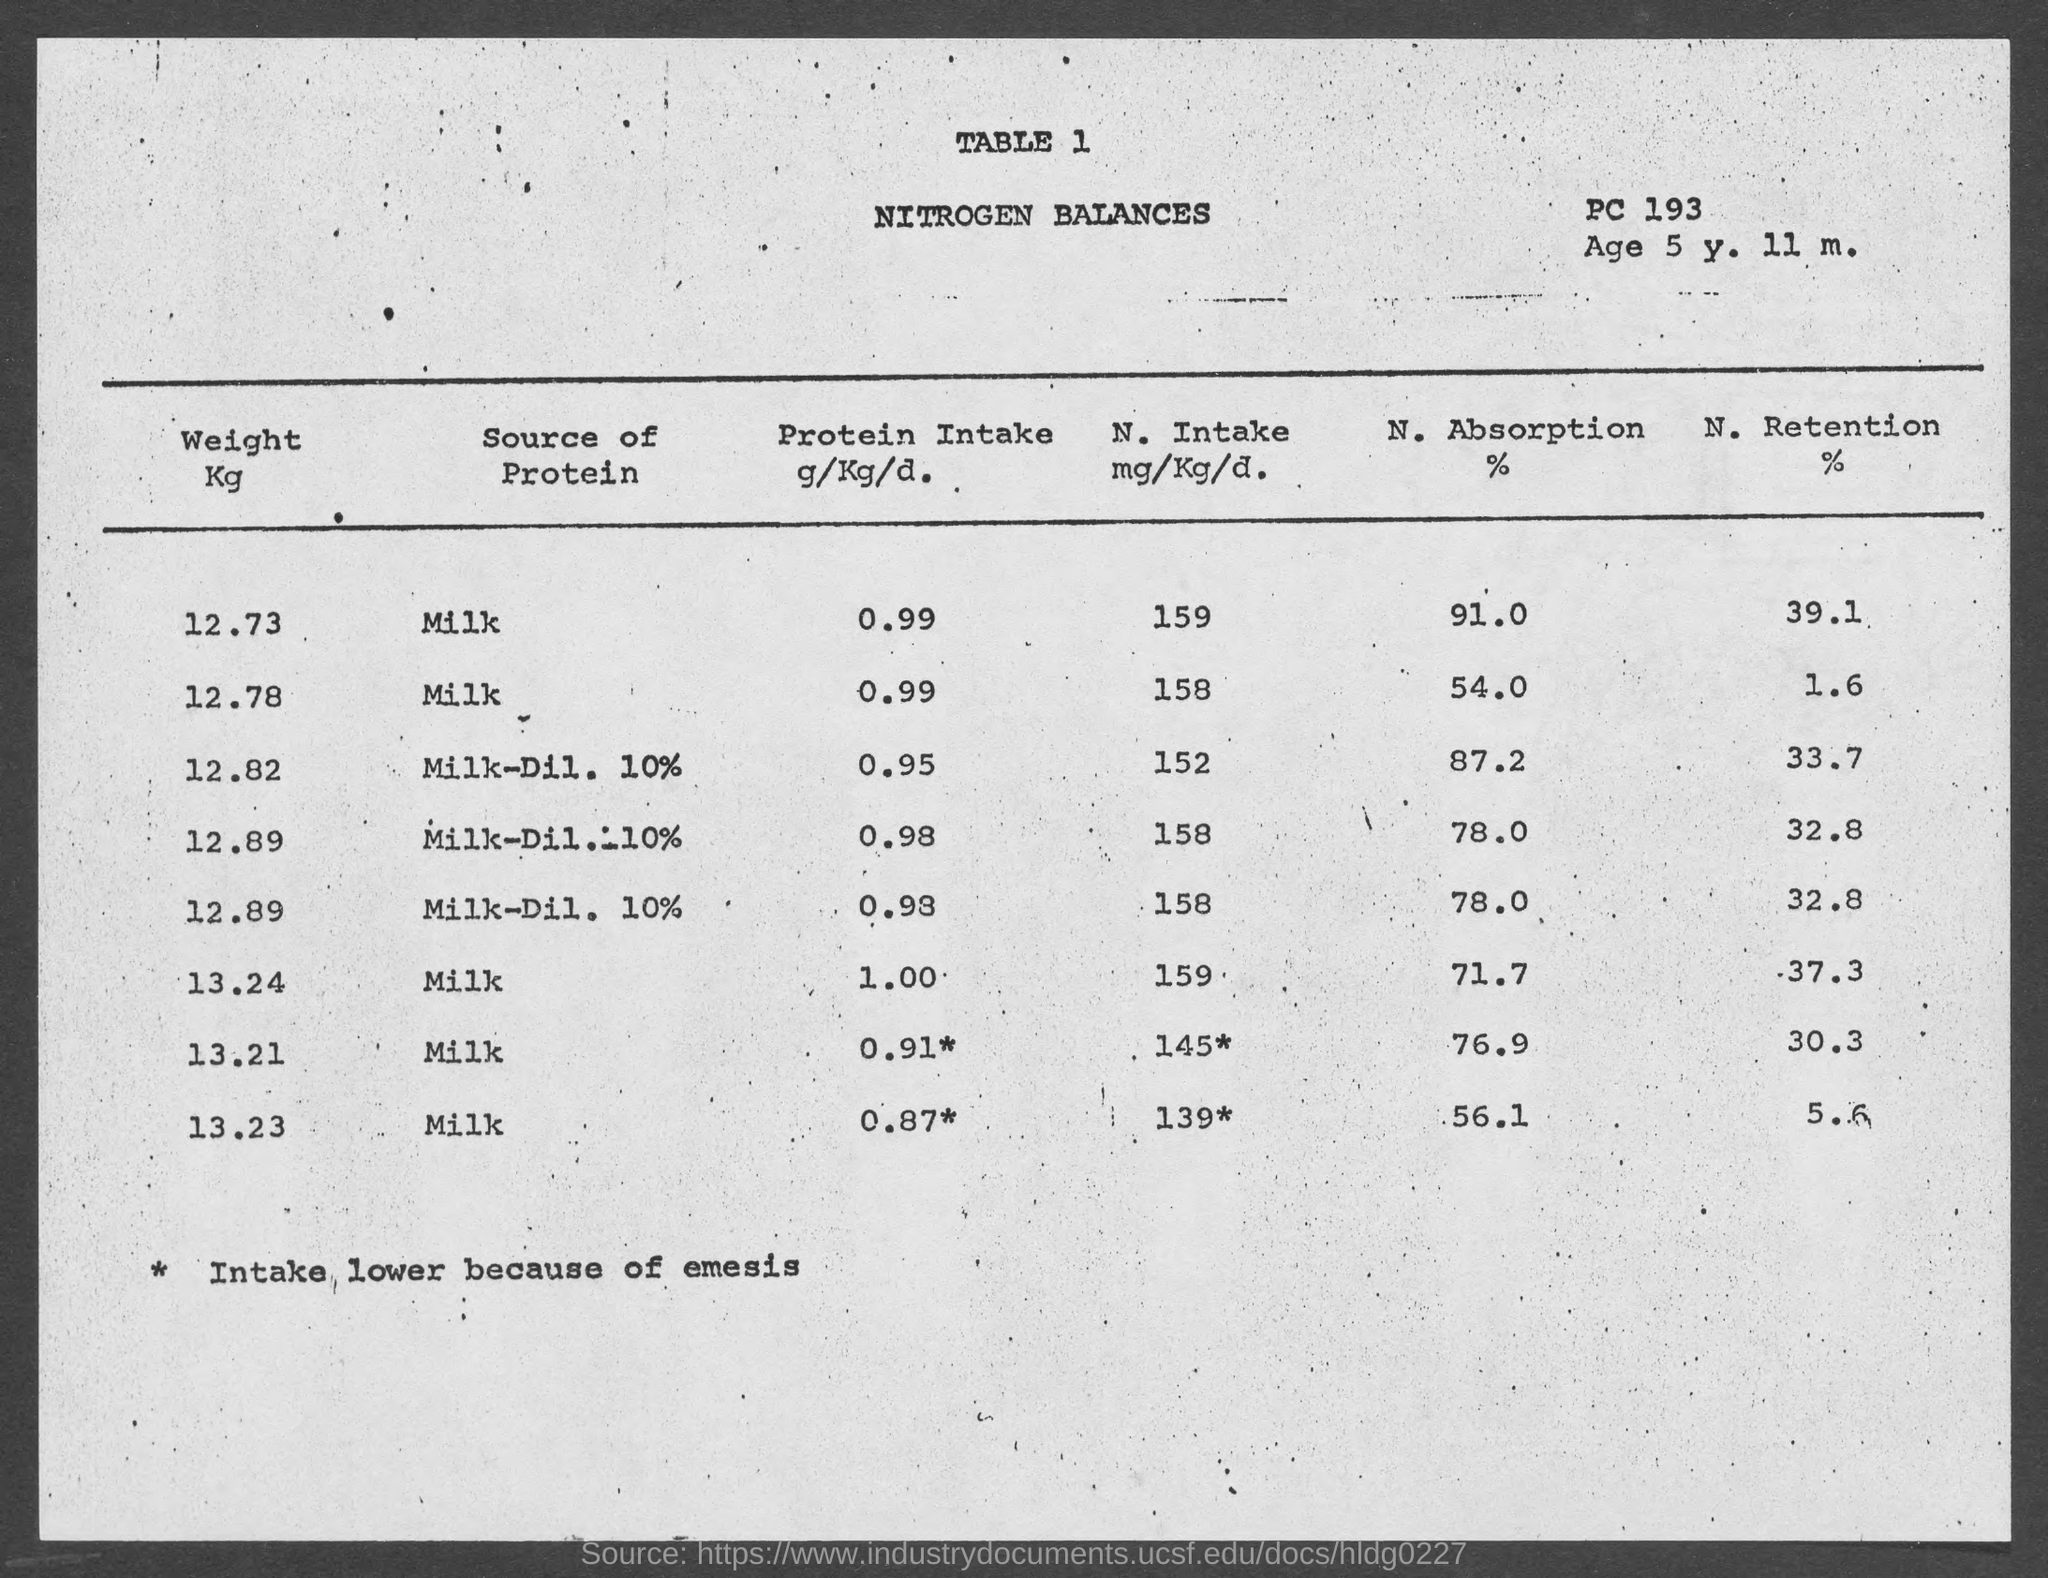Identify some key points in this picture. The percentage of nitrogen retained by a child with a weight of 13.21 would be approximately 30.3%. The document mentions an age of 5 years and 11 months. It is not clear what you are asking. Could you please provide more context or clarify your question? The percentage of nitrogen retained by a child with a weight of 12.73 is 39.1%. The title of the table is "Nitrogen Balances.. 